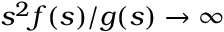<formula> <loc_0><loc_0><loc_500><loc_500>s ^ { 2 } f ( s ) / g ( s ) \rightarrow \infty</formula> 